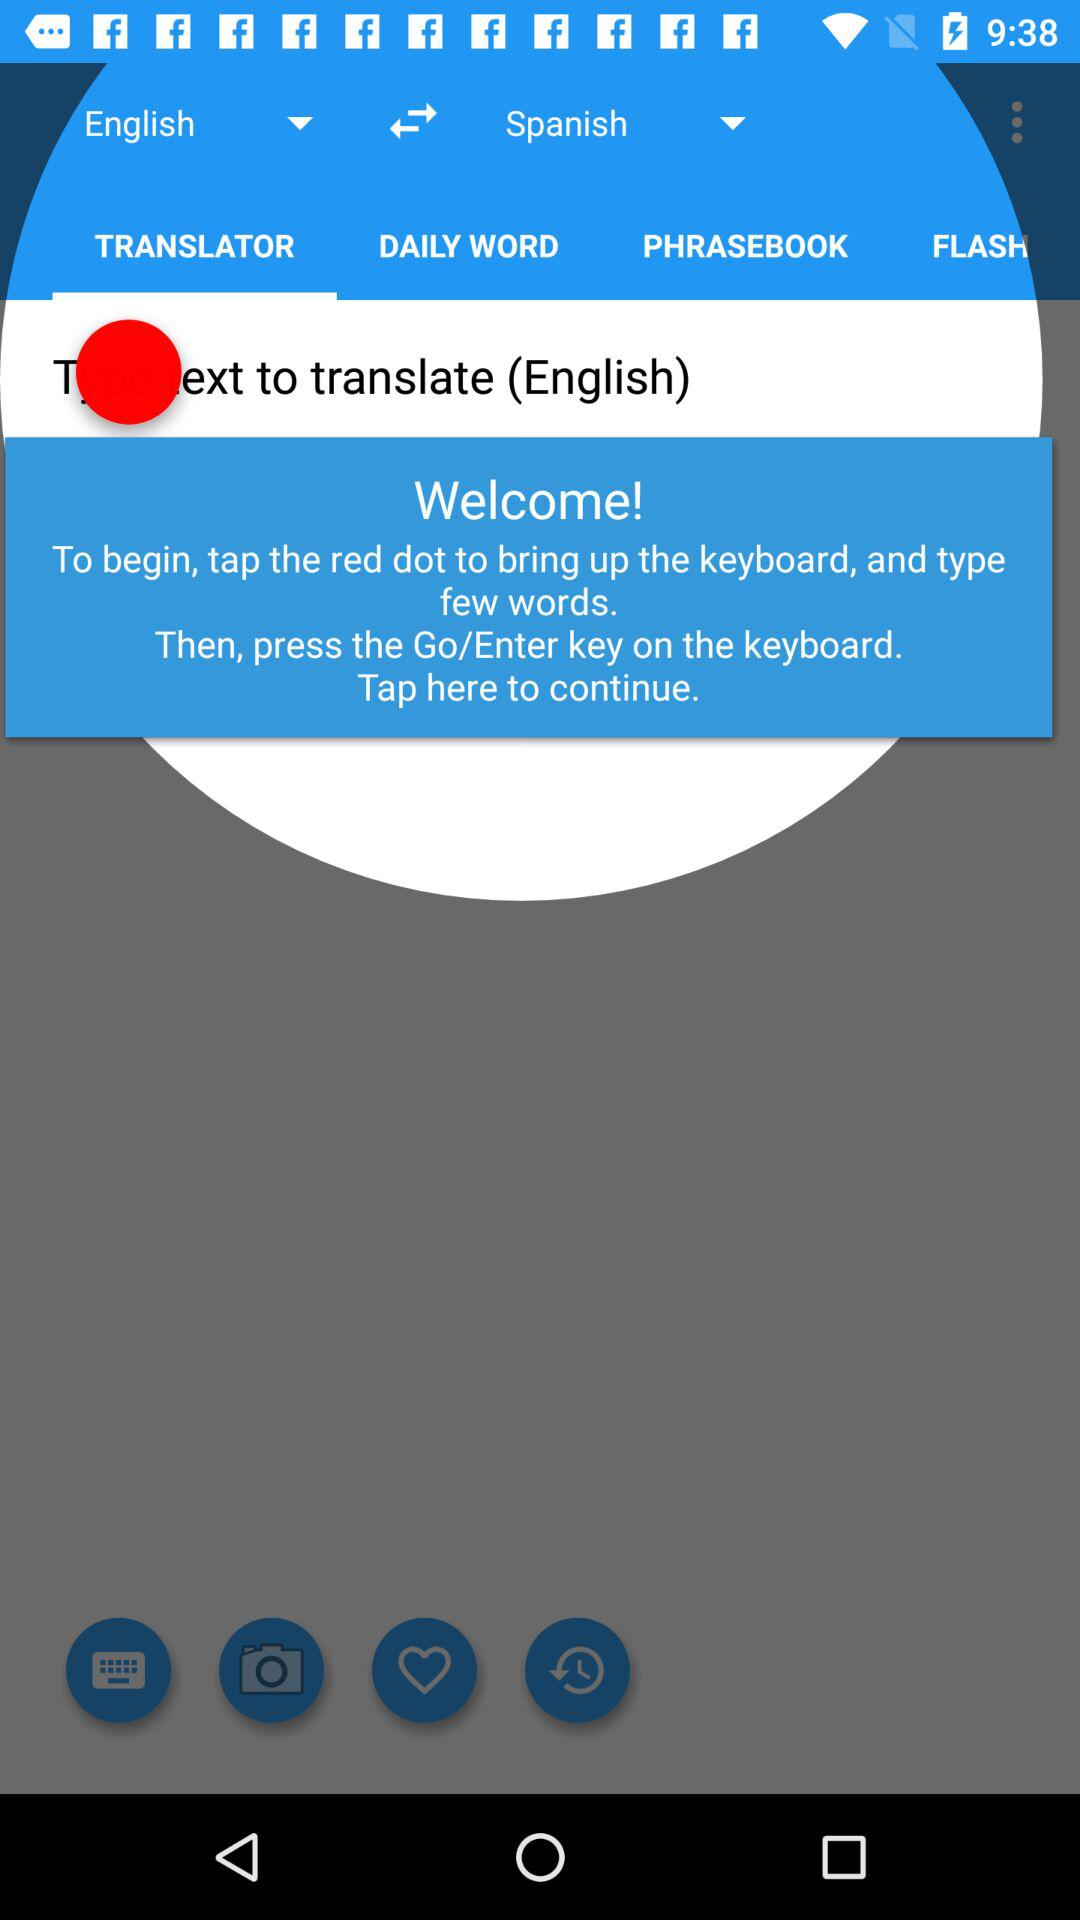Which language is selected by default, English or Spanish?
Answer the question using a single word or phrase. English 